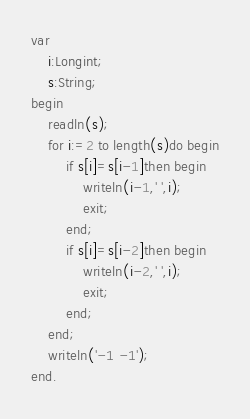<code> <loc_0><loc_0><loc_500><loc_500><_Pascal_>var
	i:Longint;
	s:String;
begin
	readln(s);
	for i:=2 to length(s)do begin
		if s[i]=s[i-1]then begin
			writeln(i-1,' ',i);
			exit;
		end;
		if s[i]=s[i-2]then begin
			writeln(i-2,' ',i);
			exit;
		end;
	end;
	writeln('-1 -1');
end.
</code> 